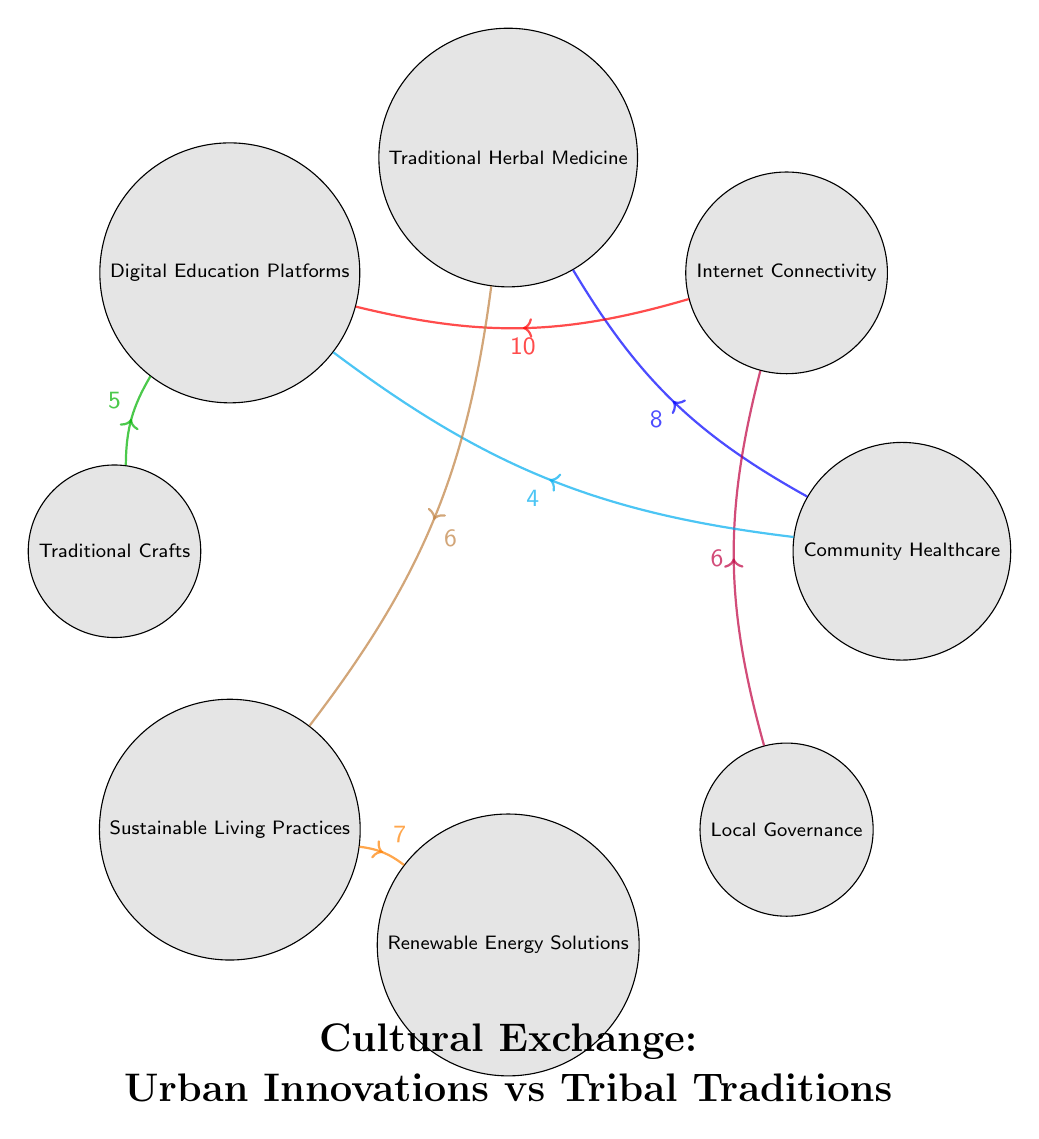What is the value of the connection between Community Healthcare and Traditional Herbal Medicine? The diagram shows a connection (link) between these two nodes with the value marked on it. The link is labeled "8", indicating the strength or significance of this connection.
Answer: 8 How many nodes are present in the diagram? By counting the total number of distinct categories or aspects represented in the diagram, we can find there are 8 nodes: Community Healthcare, Internet Connectivity, Traditional Herbal Medicine, Digital Education Platforms, Traditional Crafts, Sustainable Living Practices, Renewable Energy Solutions, Local Governance.
Answer: 8 Which node has the strongest connection to Digital Education Platforms? To find which node has the strongest connection to Digital Education Platforms, we look at the links leading to it. The link from Internet Connectivity is marked with the value "10", which is higher than the other values leading to Digital Education Platforms (5 and 4).
Answer: Internet Connectivity What is the value of the connection between Sustainable Living Practices and Renewable Energy Solutions? The diagram indicates a direct connection between these two nodes, clearly labeled with the value "7". This tells us the significance of the relationship.
Answer: 7 How many connections lead into the Internet Connectivity node? By examining the diagram, we can identify the connections leading into Internet Connectivity. There are two links: one from Local Governance (value 6) and another from Internet Connectivity itself, leading to Digital Education Platforms (value 10). Thus, there are two connections leading into it.
Answer: 2 Which two nodes are connected by a value of 5? Looking at the connections, we find that Traditional Crafts is connected to Digital Education Platforms, which is labeled with the value "5". This specifies the strength of their relationship in the context of cultural exchange.
Answer: Traditional Crafts and Digital Education Platforms What types of practices are linked through Traditional Herbal Medicine? The diagram shows two connections emerging from Traditional Herbal Medicine: one to Community Healthcare (value 8) and another to Sustainable Living Practices (value 6). This indicates that Traditional Herbal Medicine is significant in both community health and sustainability practices.
Answer: Community Healthcare and Sustainable Living Practices Which node exhibits the least number of connections? By reviewing the number of connections for each node, we see that Digital Education Platforms has three connections (from Internet Connectivity, Traditional Crafts, and Community Healthcare) while Traditional Crafts has only one connection leading into Digital Education Platforms. Hence, Traditional Crafts has the least number of connections.
Answer: Traditional Crafts 